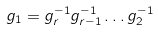Convert formula to latex. <formula><loc_0><loc_0><loc_500><loc_500>g _ { 1 } = g _ { r } ^ { - 1 } g _ { r - 1 } ^ { - 1 } \dots g _ { 2 } ^ { - 1 }</formula> 